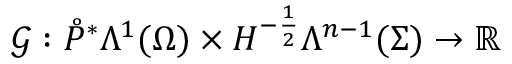Convert formula to latex. <formula><loc_0><loc_0><loc_500><loc_500>\mathcal { G } \colon \mathring { P } ^ { \ast } \Lambda ^ { 1 } ( \Omega ) \times H ^ { - \frac { 1 } { 2 } } \Lambda ^ { n - 1 } ( \Sigma ) \rightarrow \mathbb { R }</formula> 